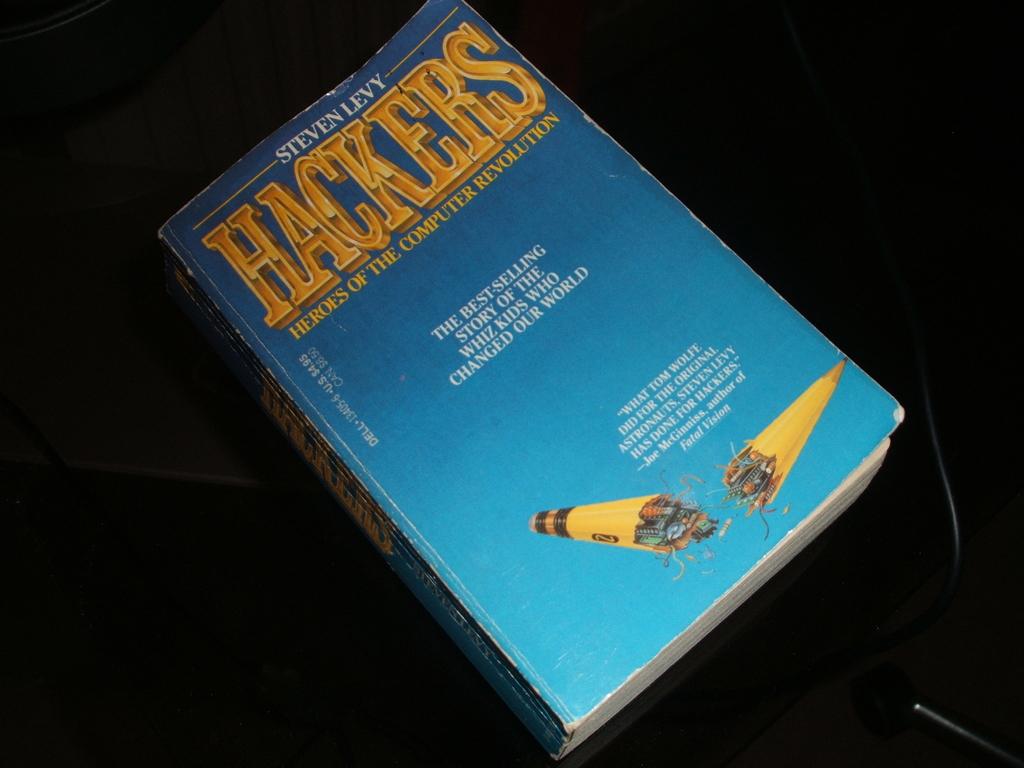Who is the author of this book?
Provide a succinct answer. Steven levy. What is the book title?
Give a very brief answer. Hackers. 